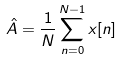<formula> <loc_0><loc_0><loc_500><loc_500>\hat { A } = \frac { 1 } { N } \sum _ { n = 0 } ^ { N - 1 } x [ n ]</formula> 